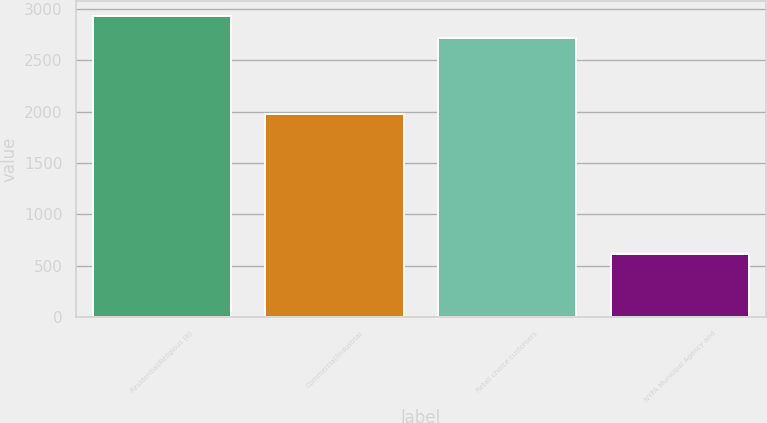Convert chart to OTSL. <chart><loc_0><loc_0><loc_500><loc_500><bar_chart><fcel>Residential/Religious (b)<fcel>Commercial/Industrial<fcel>Retail choice customers<fcel>NYPA Municipal Agency and<nl><fcel>2929.9<fcel>1974<fcel>2714<fcel>612<nl></chart> 